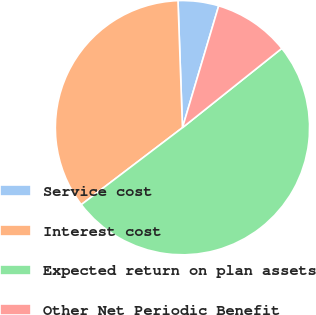<chart> <loc_0><loc_0><loc_500><loc_500><pie_chart><fcel>Service cost<fcel>Interest cost<fcel>Expected return on plan assets<fcel>Other Net Periodic Benefit<nl><fcel>5.16%<fcel>34.79%<fcel>50.37%<fcel>9.68%<nl></chart> 